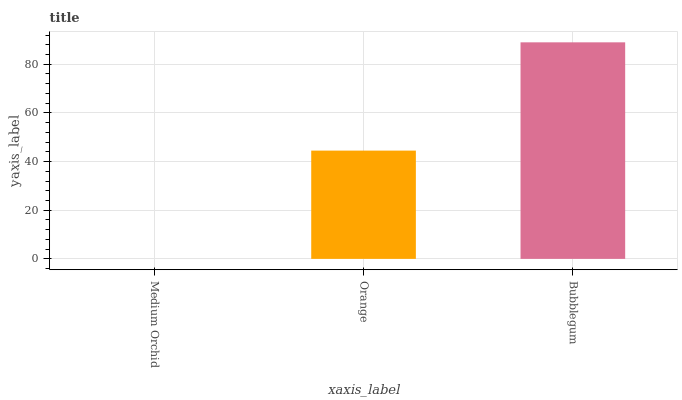Is Medium Orchid the minimum?
Answer yes or no. Yes. Is Bubblegum the maximum?
Answer yes or no. Yes. Is Orange the minimum?
Answer yes or no. No. Is Orange the maximum?
Answer yes or no. No. Is Orange greater than Medium Orchid?
Answer yes or no. Yes. Is Medium Orchid less than Orange?
Answer yes or no. Yes. Is Medium Orchid greater than Orange?
Answer yes or no. No. Is Orange less than Medium Orchid?
Answer yes or no. No. Is Orange the high median?
Answer yes or no. Yes. Is Orange the low median?
Answer yes or no. Yes. Is Medium Orchid the high median?
Answer yes or no. No. Is Medium Orchid the low median?
Answer yes or no. No. 